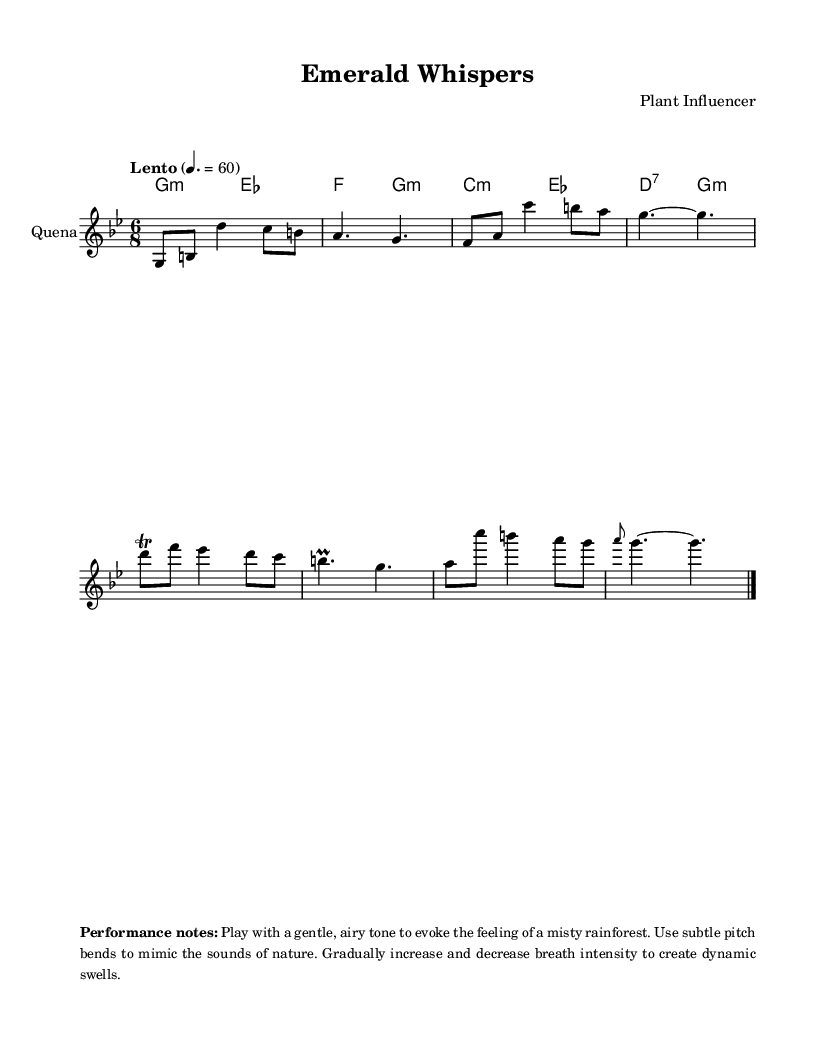What is the key signature of this music? The key signature shown in the sheet music has two flats (B♭ and E♭), indicating it is in G minor.
Answer: G minor What is the time signature of this piece? The time signature displayed at the beginning of the music is 6/8, which indicates six eighth notes per measure.
Answer: 6/8 What is the tempo marking for this piece? The sheet music indicates a tempo marking of "Lento" with a metronome marking of 60, meaning the piece should be played slowly.
Answer: Lento What instrument is the melody written for? The melody is notated for the "Quena", a traditional Andean flute, as specified at the beginning of the staff in the score.
Answer: Quena What is the first note of the melody? The first note in the melody is G, indicated in the relative pitch notation at the beginning of the staff.
Answer: G What type of embellishment is used in the melody? The melody features a trill on the note D, which means to alternate rapidly between D and the note above it (E♭).
Answer: Trill How should the piece be performed according to the performance notes? The performance notes suggest playing with a gentle, airy tone and using breath intensity to create dynamic swells, reflecting the environment of a misty rainforest.
Answer: Gentle, airy tone 